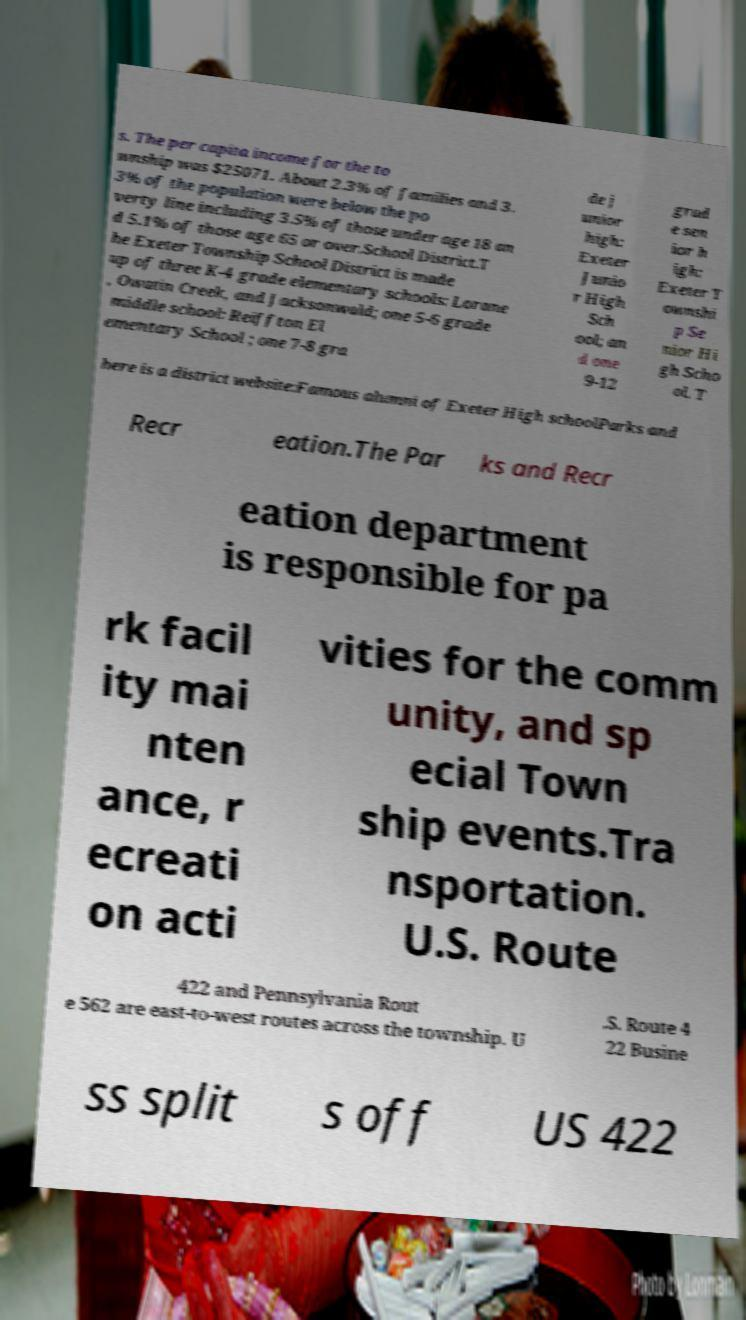Please read and relay the text visible in this image. What does it say? s. The per capita income for the to wnship was $25071. About 2.3% of families and 3. 3% of the population were below the po verty line including 3.5% of those under age 18 an d 5.1% of those age 65 or over.School District.T he Exeter Township School District is made up of three K-4 grade elementary schools: Lorane , Owatin Creek, and Jacksonwald; one 5-6 grade middle school: Reiffton El ementary School ; one 7-8 gra de j unior high: Exeter Junio r High Sch ool; an d one 9-12 grad e sen ior h igh: Exeter T ownshi p Se nior Hi gh Scho ol. T here is a district website:Famous alumni of Exeter High schoolParks and Recr eation.The Par ks and Recr eation department is responsible for pa rk facil ity mai nten ance, r ecreati on acti vities for the comm unity, and sp ecial Town ship events.Tra nsportation. U.S. Route 422 and Pennsylvania Rout e 562 are east-to-west routes across the township. U .S. Route 4 22 Busine ss split s off US 422 